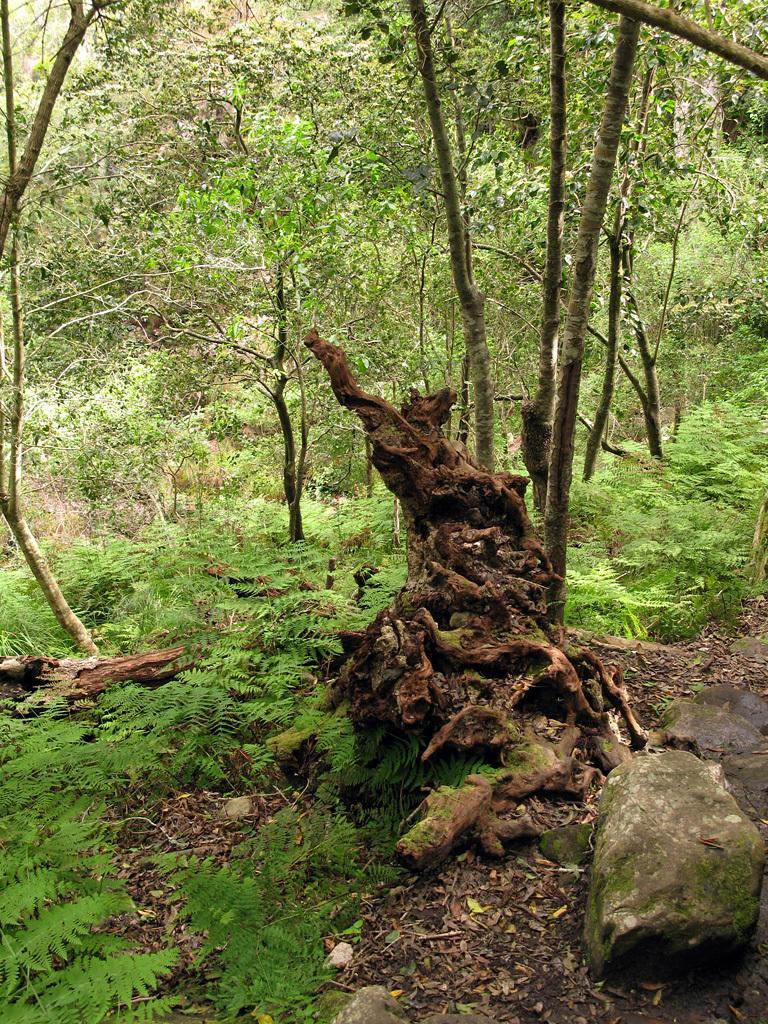What type of natural material is scattered on the ground in the image? There are shredded leaves on the ground in the image. What other natural elements can be seen in the image? There are rocks, plants, logs, and trees in the image. What type of songs can be heard coming from the trees in the image? There are no songs or sounds coming from the trees in the image. What type of cloth is draped over the logs in the image? There is no cloth present in the image; it only features shredded leaves, rocks, plants, logs, and trees. 